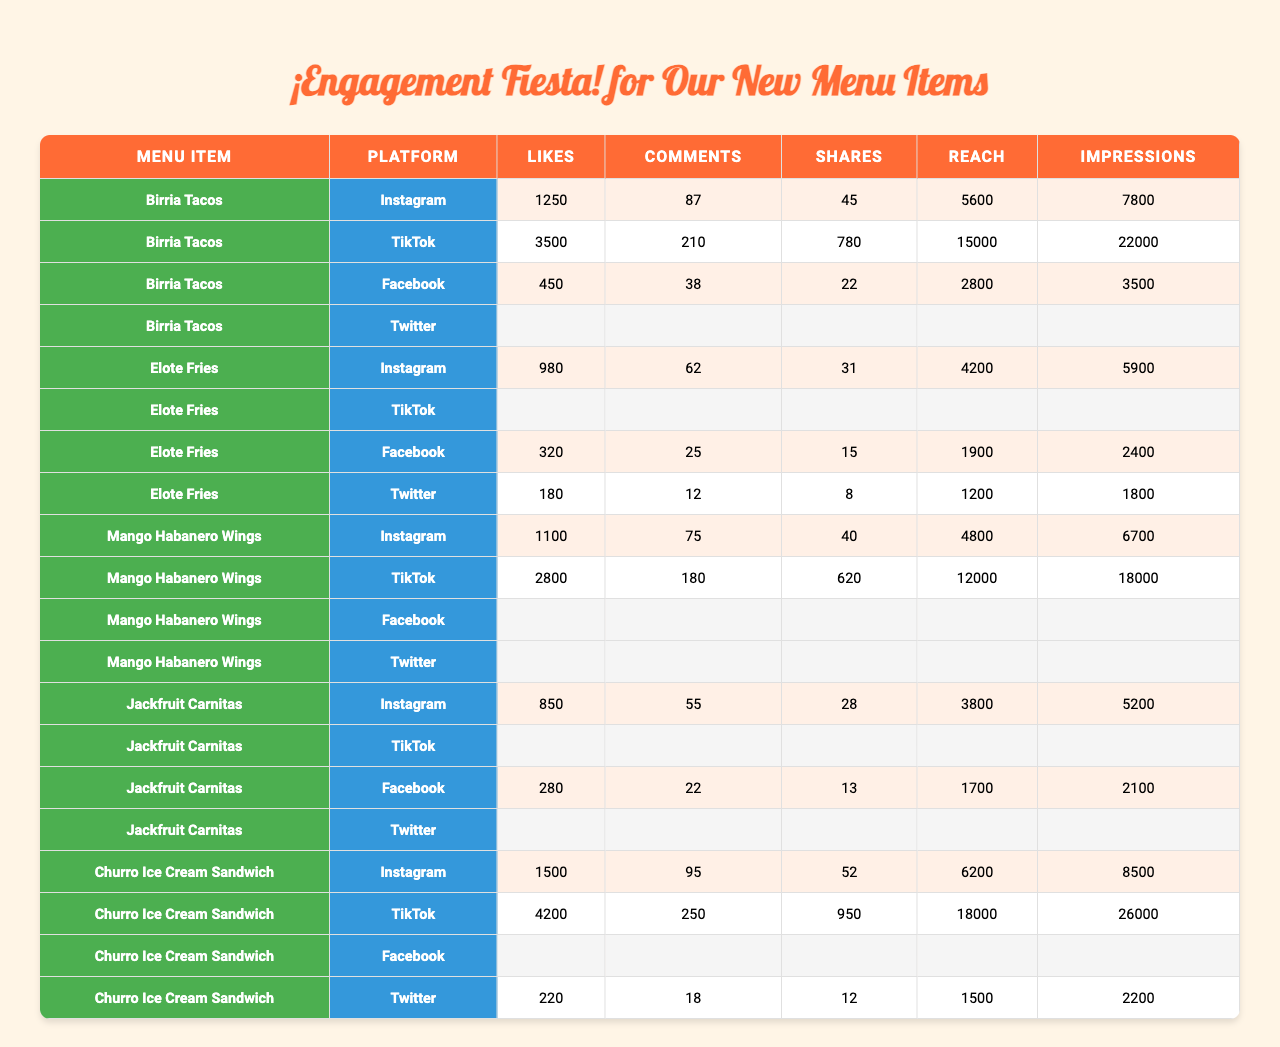What menu item received the most Likes on TikTok? Birria Tacos received the most Likes on TikTok with 3500.
Answer: Birria Tacos Which platform had the highest Reach for Churro Ice Cream Sandwich? The highest Reach for Churro Ice Cream Sandwich was on TikTok with 18000.
Answer: TikTok What is the total number of Shares for Elote Fries across all platforms? Elote Fries had Shares of 31 on Instagram, 15 on Facebook, and 8 on Twitter. Summing them gives 31 + 15 + 8 = 54.
Answer: 54 Did Mango Habanero Wings receive any Shares on Facebook? No, Mango Habanero Wings did not have any Shares recorded on Facebook.
Answer: No Which menu item averaged the highest number of Likes across its available platforms? To find the average Likes, calculate for each item: Birria Tacos: (1250 + 3500 + 450)/3 = 1733.33; Elote Fries: (980 + 320 + 180)/3 = 493.33; Mango Habanero Wings: (1100 + 2800)/2 = 1950; Jackfruit Carnitas: (850 + 280)/2 = 565; Churro Ice Cream Sandwich: (1500 + 4200 + 220)/3 = 1960. Average for Mango Habanero Wings is 1950, making it the highest averaged item after reconsideration of all values.
Answer: Churro Ice Cream Sandwich What is the difference in Likes between Churro Ice Cream Sandwich and Jackfruit Carnitas on Instagram? Churro Ice Cream Sandwich received 1500 Likes and Jackfruit Carnitas received 850 Likes on Instagram. The difference is 1500 - 850 = 650.
Answer: 650 On which platform did Elote Fries have the lowest Reach? Elote Fries had the lowest Reach on Twitter with 1200.
Answer: Twitter Which social platform had the highest number of Impressions for Mango Habanero Wings? The highest number of Impressions for Mango Habanero Wings was on TikTok with 18000.
Answer: TikTok How many total Comments were made for Birria Tacos across all platforms? The total Comments for Birria Tacos are 87 (Instagram) + 210 (TikTok) + 38 (Facebook) = 335.
Answer: 335 Which menu item has the lowest number of Shares on Instagram? Jackfruit Carnitas has the lowest number of Shares on Instagram with 28.
Answer: Jackfruit Carnitas Are Likes for any menu item on Facebook greater than 500? Yes, Birria Tacos has 450 Likes and Churro Ice Cream Sandwich has 220 Likes on Facebook, which are both less than 500, thereby no values are recorded as higher than 500 in Likes on Facebook.
Answer: No 